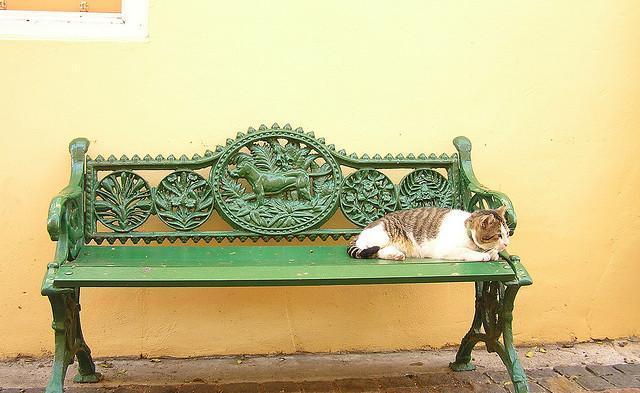How many elephants are there?
Give a very brief answer. 0. 